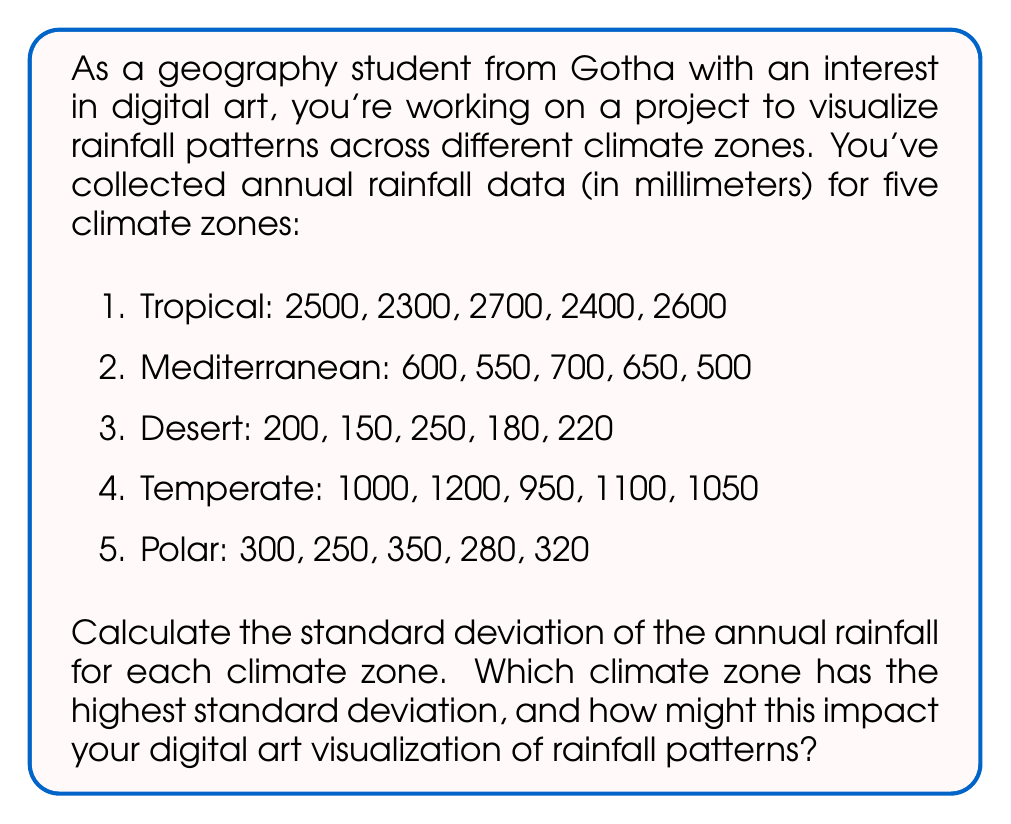Help me with this question. To calculate the standard deviation for each climate zone, we'll follow these steps:

1. Calculate the mean ($\bar{x}$) of the data set
2. Calculate the squared differences from the mean
3. Calculate the variance ($s^2$)
4. Calculate the standard deviation ($s$)

The formula for standard deviation is:

$$ s = \sqrt{\frac{\sum_{i=1}^{n} (x_i - \bar{x})^2}{n - 1}} $$

Let's calculate for each climate zone:

1. Tropical:
   Mean: $\bar{x} = \frac{2500 + 2300 + 2700 + 2400 + 2600}{5} = 2500$
   Squared differences: $(0^2 + (-200)^2 + 200^2 + (-100)^2 + 100^2) = 130,000$
   Variance: $s^2 = \frac{130,000}{4} = 32,500$
   Standard deviation: $s = \sqrt{32,500} = 180.28$ mm

2. Mediterranean:
   Mean: $\bar{x} = 600$
   Squared differences: $0^2 + (-50)^2 + 100^2 + 50^2 + (-100)^2 = 32,500$
   Variance: $s^2 = \frac{32,500}{4} = 8,125$
   Standard deviation: $s = \sqrt{8,125} = 90.14$ mm

3. Desert:
   Mean: $\bar{x} = 200$
   Squared differences: $0^2 + (-50)^2 + 50^2 + (-20)^2 + 20^2 = 5,800$
   Variance: $s^2 = \frac{5,800}{4} = 1,450$
   Standard deviation: $s = \sqrt{1,450} = 38.08$ mm

4. Temperate:
   Mean: $\bar{x} = 1060$
   Squared differences: $(-60)^2 + 140^2 + (-110)^2 + 40^2 + (-10)^2 = 45,000$
   Variance: $s^2 = \frac{45,000}{4} = 11,250$
   Standard deviation: $s = \sqrt{11,250} = 106.07$ mm

5. Polar:
   Mean: $\bar{x} = 300$
   Squared differences: $0^2 + (-50)^2 + 50^2 + (-20)^2 + 20^2 = 5,800$
   Variance: $s^2 = \frac{5,800}{4} = 1,450$
   Standard deviation: $s = \sqrt{1,450} = 38.08$ mm

The climate zone with the highest standard deviation is Tropical, with 180.28 mm.

This higher standard deviation in the Tropical climate zone indicates greater variability in annual rainfall. For a digital art visualization, this could be represented by using a wider range of colors or more intense contrasts in the tropical regions, emphasizing the greater fluctuations in rainfall. In contrast, areas with lower standard deviations like the Desert and Polar zones could be depicted with more subtle variations, reflecting their more consistent annual rainfall patterns.
Answer: The standard deviations for each climate zone are:
Tropical: 180.28 mm
Mediterranean: 90.14 mm
Desert: 38.08 mm
Temperate: 106.07 mm
Polar: 38.08 mm

The Tropical climate zone has the highest standard deviation at 180.28 mm, indicating the greatest variability in annual rainfall. 